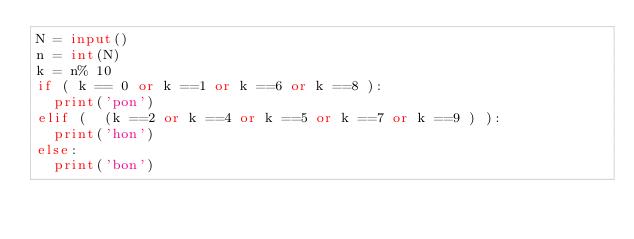<code> <loc_0><loc_0><loc_500><loc_500><_Python_>N = input()
n = int(N)
k = n% 10
if ( k == 0 or k ==1 or k ==6 or k ==8 ):
  print('pon')
elif (  (k ==2 or k ==4 or k ==5 or k ==7 or k ==9 ) ):
  print('hon')
else:
  print('bon')
</code> 